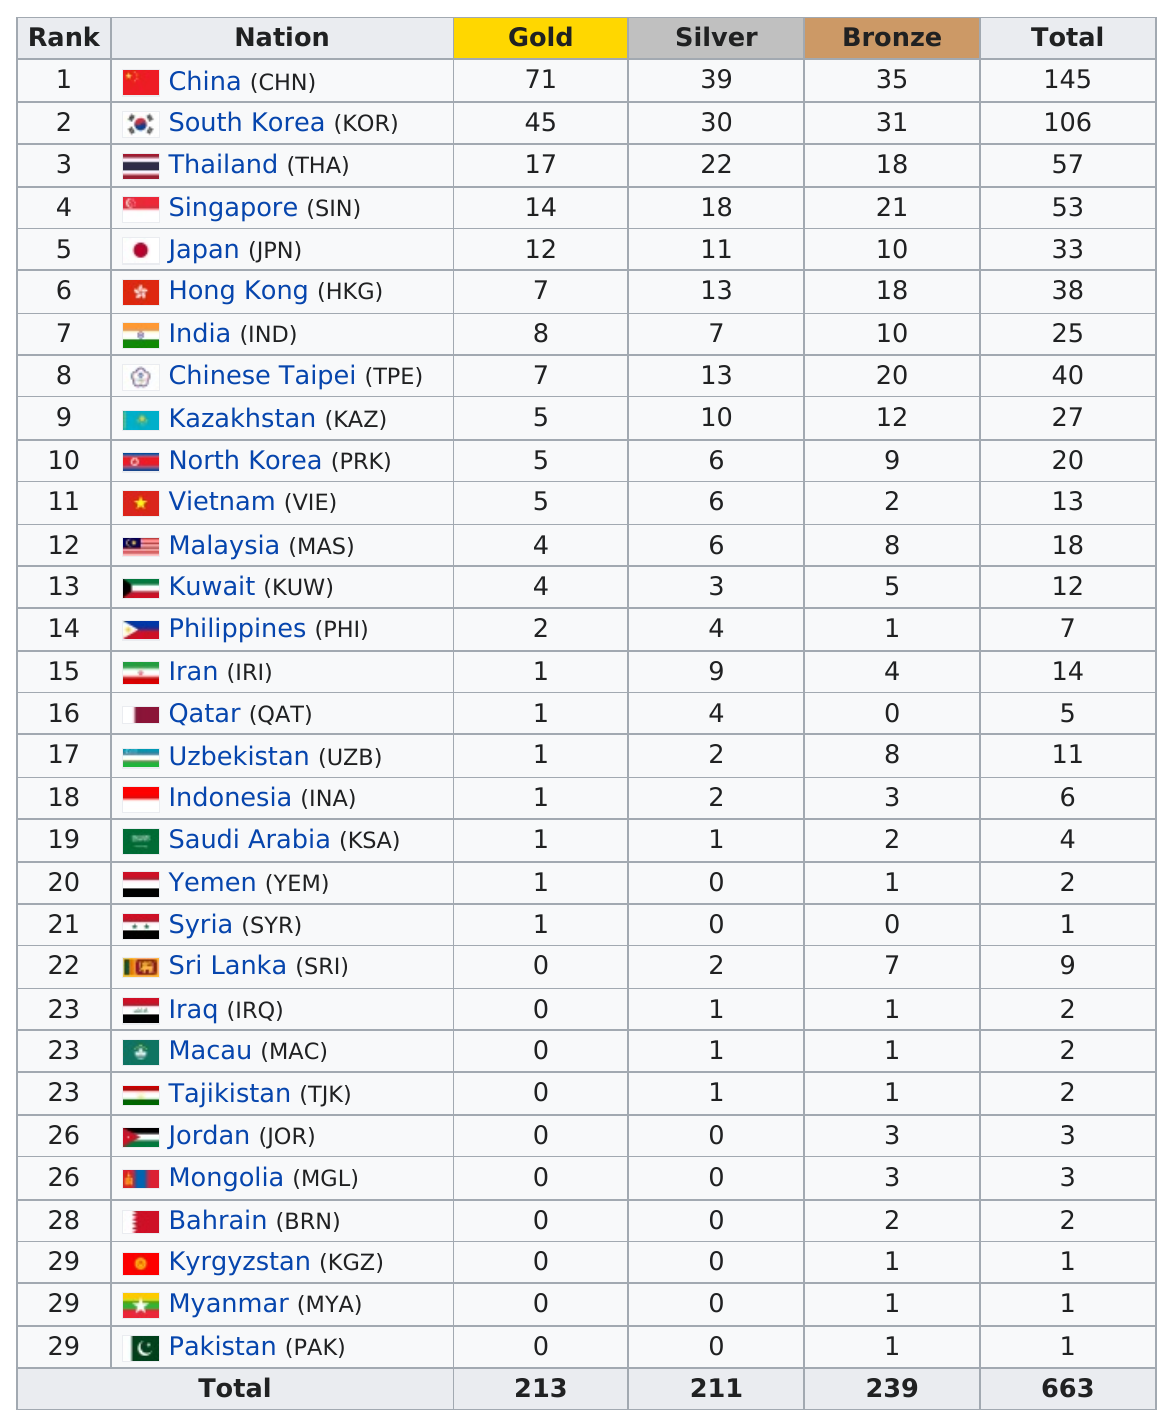Specify some key components in this picture. Singapore has won 11 bronze medals in the Asian Youth Games, while Japan has won 11 bronze medals in the same competition. There are two countries, Vietnam (VIE) and Malaysia (MAS), that have the same number of silver medals in the Asian Youth Games as North Korea. Nine nations have earned at least ten bronze medals. Qatar must win at least one more gold medal in order to earn a total of 12 gold medals. Japan has won 19 more medals than Iran in their respective sports competitions. 